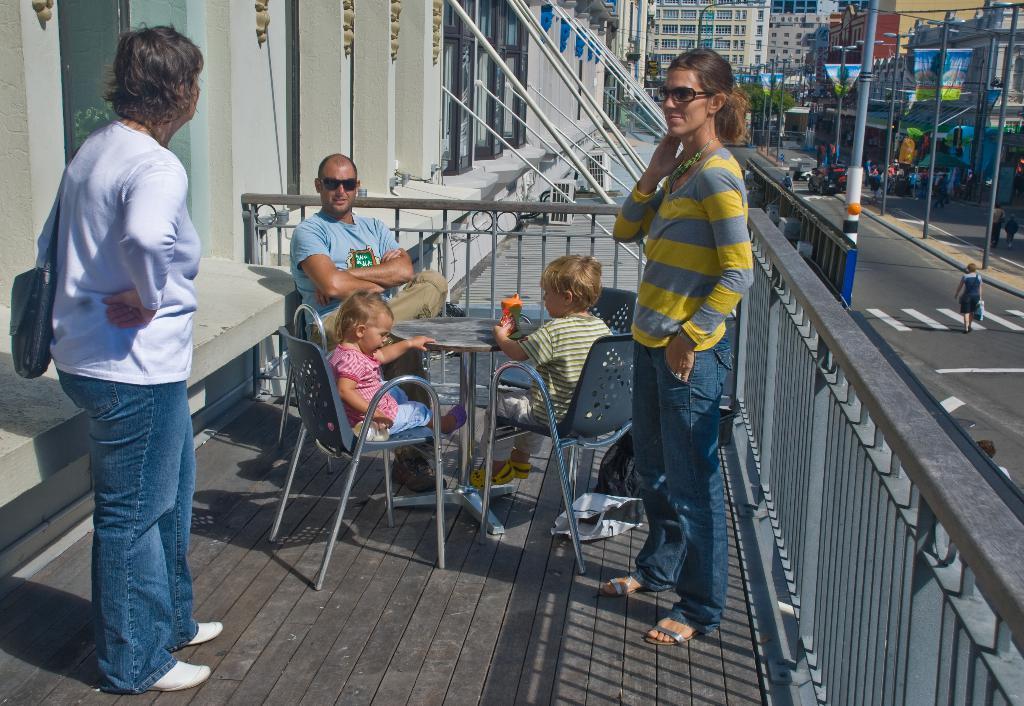In one or two sentences, can you explain what this image depicts? The image is outside of the city. In the image on right side and left side there are two persons standing in middle there are two kids and a man sitting on chair in front of a table. In background we can see some buildings,street lights and group of people standing and walking at bottom there is a road which is in black color. 